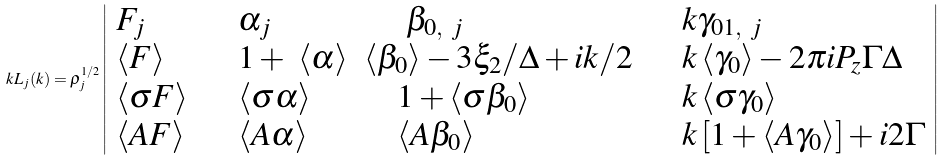Convert formula to latex. <formula><loc_0><loc_0><loc_500><loc_500>k L _ { j } ( k ) = \rho _ { j } ^ { 1 / 2 } \left | \begin{array} { l l l l } F _ { j } & \quad \alpha _ { j } & \ \quad \beta _ { 0 , \ j } & \quad k \gamma _ { 0 1 , \ j } \\ \left \langle F \right \rangle & \quad 1 + \ \left \langle \alpha \right \rangle & \left \langle \beta _ { 0 } \right \rangle - 3 \xi _ { 2 } / \Delta + i k / 2 & \quad k \left \langle \gamma _ { 0 } \right \rangle - 2 \pi i P _ { z } \Gamma \Delta \\ \left \langle \sigma F \right \rangle & \quad \left \langle \sigma \alpha \right \rangle & \quad 1 + \left \langle \sigma \beta _ { 0 } \right \rangle & \quad k \left \langle \sigma \gamma _ { 0 } \right \rangle \\ \left \langle A F \right \rangle & \quad \left \langle A \alpha \right \rangle & \quad \left \langle A \beta _ { 0 } \right \rangle & \quad k \left [ 1 + \left \langle A \gamma _ { 0 } \right \rangle \right ] + i 2 \Gamma \end{array} \right |</formula> 